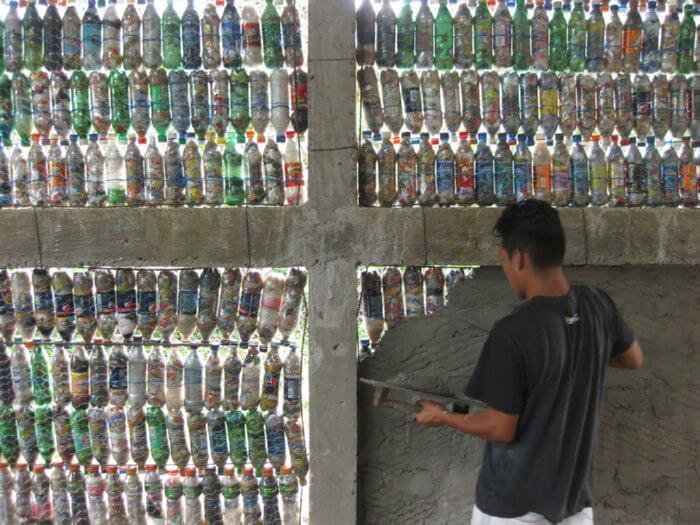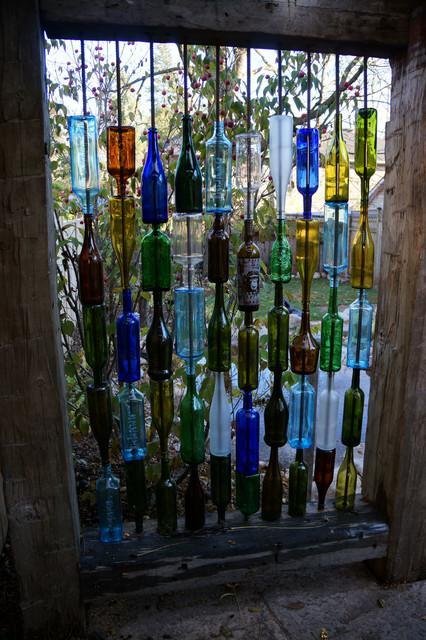The first image is the image on the left, the second image is the image on the right. Assess this claim about the two images: "The right image shows label-less glass bottles of various colors strung on rows of vertical bars, with some rightside-up and some upside-down.". Correct or not? Answer yes or no. Yes. The first image is the image on the left, the second image is the image on the right. Analyze the images presented: Is the assertion "Some bottles have liquor in them." valid? Answer yes or no. No. 